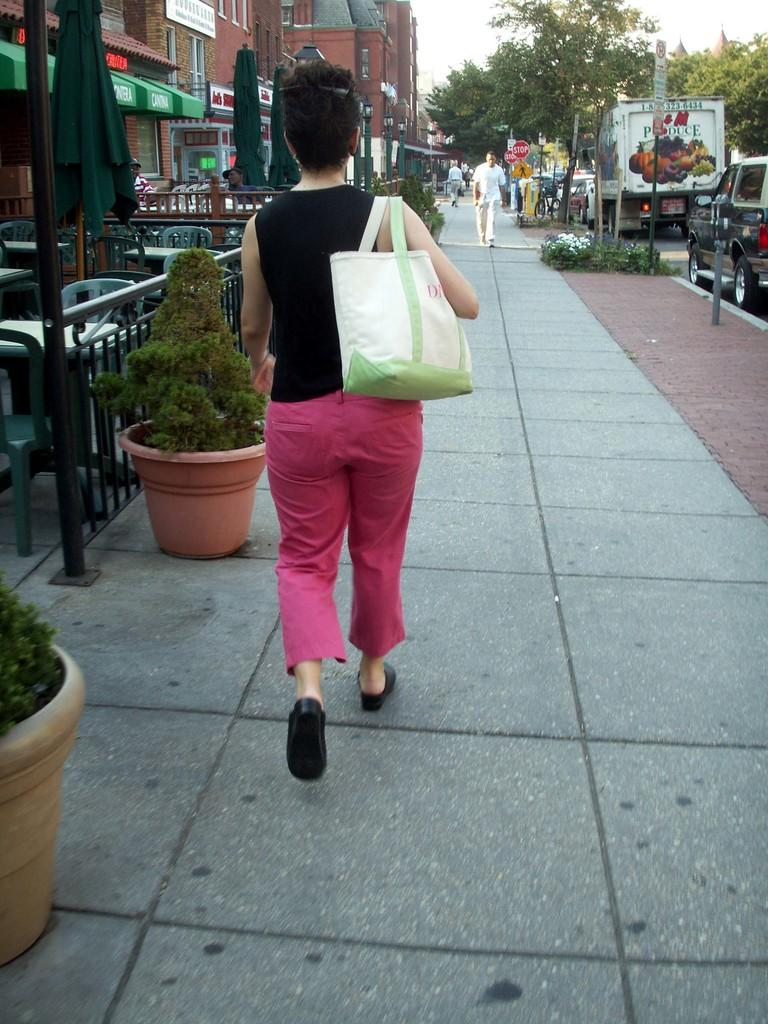What is the woman in the image doing? The woman is walking on the road in the image. What type of natural elements can be seen in the image? Plants and trees are visible in the image. What type of man-made structures can be seen in the image? There are buildings in the image. What part of the natural environment is visible in the image? The sky is visible in the image. What type of copper roof can be seen on the woman's shoes in the image? There is no copper roof present on the woman's shoes in the image, as the woman is wearing regular shoes and there is no mention of a roof in the provided facts. 